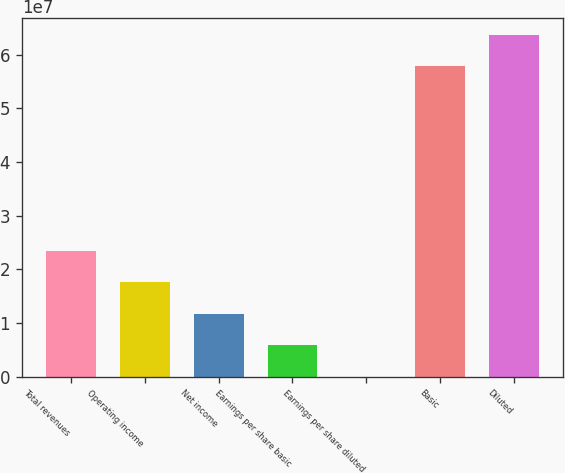Convert chart. <chart><loc_0><loc_0><loc_500><loc_500><bar_chart><fcel>Total revenues<fcel>Operating income<fcel>Net income<fcel>Earnings per share basic<fcel>Earnings per share diluted<fcel>Basic<fcel>Diluted<nl><fcel>2.3516e+07<fcel>1.7637e+07<fcel>1.1758e+07<fcel>5.879e+06<fcel>2.1<fcel>5.78392e+07<fcel>6.37182e+07<nl></chart> 